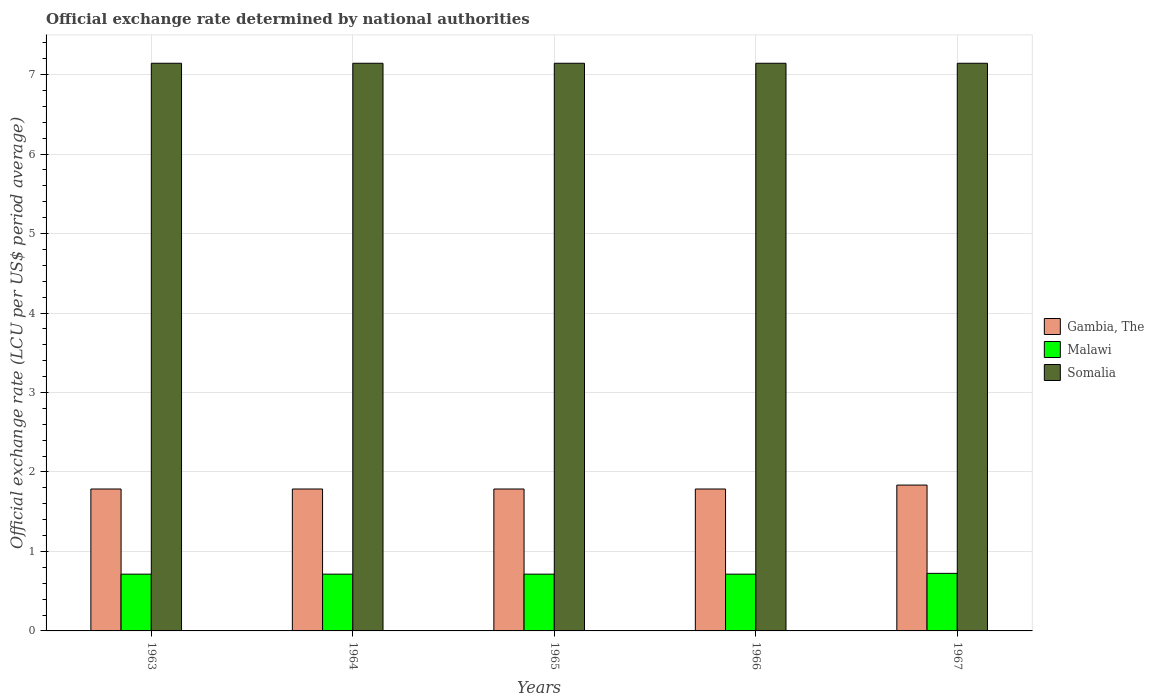How many groups of bars are there?
Your response must be concise. 5. Are the number of bars per tick equal to the number of legend labels?
Provide a succinct answer. Yes. How many bars are there on the 2nd tick from the left?
Offer a very short reply. 3. What is the label of the 5th group of bars from the left?
Ensure brevity in your answer.  1967. In how many cases, is the number of bars for a given year not equal to the number of legend labels?
Your answer should be compact. 0. What is the official exchange rate in Malawi in 1964?
Keep it short and to the point. 0.71. Across all years, what is the maximum official exchange rate in Gambia, The?
Your response must be concise. 1.84. Across all years, what is the minimum official exchange rate in Malawi?
Provide a succinct answer. 0.71. In which year was the official exchange rate in Malawi maximum?
Your answer should be very brief. 1967. What is the total official exchange rate in Gambia, The in the graph?
Provide a short and direct response. 8.98. What is the difference between the official exchange rate in Somalia in 1965 and the official exchange rate in Gambia, The in 1967?
Provide a short and direct response. 5.31. What is the average official exchange rate in Gambia, The per year?
Offer a terse response. 1.8. In the year 1964, what is the difference between the official exchange rate in Somalia and official exchange rate in Gambia, The?
Offer a terse response. 5.36. What is the ratio of the official exchange rate in Malawi in 1963 to that in 1964?
Offer a terse response. 1. Is the official exchange rate in Gambia, The in 1965 less than that in 1966?
Provide a short and direct response. No. What is the difference between the highest and the second highest official exchange rate in Gambia, The?
Offer a very short reply. 0.05. In how many years, is the official exchange rate in Malawi greater than the average official exchange rate in Malawi taken over all years?
Your answer should be very brief. 1. Is the sum of the official exchange rate in Somalia in 1963 and 1964 greater than the maximum official exchange rate in Malawi across all years?
Your answer should be compact. Yes. What does the 3rd bar from the left in 1963 represents?
Your response must be concise. Somalia. What does the 3rd bar from the right in 1967 represents?
Your answer should be very brief. Gambia, The. Does the graph contain grids?
Offer a terse response. Yes. What is the title of the graph?
Provide a succinct answer. Official exchange rate determined by national authorities. Does "Serbia" appear as one of the legend labels in the graph?
Provide a short and direct response. No. What is the label or title of the Y-axis?
Keep it short and to the point. Official exchange rate (LCU per US$ period average). What is the Official exchange rate (LCU per US$ period average) of Gambia, The in 1963?
Your response must be concise. 1.79. What is the Official exchange rate (LCU per US$ period average) of Malawi in 1963?
Offer a very short reply. 0.71. What is the Official exchange rate (LCU per US$ period average) of Somalia in 1963?
Your answer should be very brief. 7.14. What is the Official exchange rate (LCU per US$ period average) of Gambia, The in 1964?
Provide a succinct answer. 1.79. What is the Official exchange rate (LCU per US$ period average) of Malawi in 1964?
Provide a short and direct response. 0.71. What is the Official exchange rate (LCU per US$ period average) of Somalia in 1964?
Your response must be concise. 7.14. What is the Official exchange rate (LCU per US$ period average) of Gambia, The in 1965?
Provide a short and direct response. 1.79. What is the Official exchange rate (LCU per US$ period average) in Malawi in 1965?
Offer a very short reply. 0.71. What is the Official exchange rate (LCU per US$ period average) of Somalia in 1965?
Your response must be concise. 7.14. What is the Official exchange rate (LCU per US$ period average) of Gambia, The in 1966?
Your response must be concise. 1.79. What is the Official exchange rate (LCU per US$ period average) of Malawi in 1966?
Provide a succinct answer. 0.71. What is the Official exchange rate (LCU per US$ period average) of Somalia in 1966?
Provide a short and direct response. 7.14. What is the Official exchange rate (LCU per US$ period average) in Gambia, The in 1967?
Your response must be concise. 1.84. What is the Official exchange rate (LCU per US$ period average) in Malawi in 1967?
Make the answer very short. 0.72. What is the Official exchange rate (LCU per US$ period average) of Somalia in 1967?
Keep it short and to the point. 7.14. Across all years, what is the maximum Official exchange rate (LCU per US$ period average) of Gambia, The?
Your response must be concise. 1.84. Across all years, what is the maximum Official exchange rate (LCU per US$ period average) in Malawi?
Give a very brief answer. 0.72. Across all years, what is the maximum Official exchange rate (LCU per US$ period average) of Somalia?
Keep it short and to the point. 7.14. Across all years, what is the minimum Official exchange rate (LCU per US$ period average) of Gambia, The?
Your answer should be compact. 1.79. Across all years, what is the minimum Official exchange rate (LCU per US$ period average) of Malawi?
Ensure brevity in your answer.  0.71. Across all years, what is the minimum Official exchange rate (LCU per US$ period average) of Somalia?
Keep it short and to the point. 7.14. What is the total Official exchange rate (LCU per US$ period average) of Gambia, The in the graph?
Provide a short and direct response. 8.98. What is the total Official exchange rate (LCU per US$ period average) of Malawi in the graph?
Give a very brief answer. 3.58. What is the total Official exchange rate (LCU per US$ period average) of Somalia in the graph?
Offer a terse response. 35.71. What is the difference between the Official exchange rate (LCU per US$ period average) of Gambia, The in 1963 and that in 1964?
Offer a very short reply. 0. What is the difference between the Official exchange rate (LCU per US$ period average) of Malawi in 1963 and that in 1965?
Make the answer very short. 0. What is the difference between the Official exchange rate (LCU per US$ period average) of Somalia in 1963 and that in 1965?
Make the answer very short. 0. What is the difference between the Official exchange rate (LCU per US$ period average) of Malawi in 1963 and that in 1966?
Your answer should be compact. 0. What is the difference between the Official exchange rate (LCU per US$ period average) in Gambia, The in 1963 and that in 1967?
Your answer should be compact. -0.05. What is the difference between the Official exchange rate (LCU per US$ period average) in Malawi in 1963 and that in 1967?
Give a very brief answer. -0.01. What is the difference between the Official exchange rate (LCU per US$ period average) in Somalia in 1963 and that in 1967?
Your response must be concise. 0. What is the difference between the Official exchange rate (LCU per US$ period average) in Somalia in 1964 and that in 1965?
Provide a short and direct response. 0. What is the difference between the Official exchange rate (LCU per US$ period average) in Gambia, The in 1964 and that in 1966?
Keep it short and to the point. 0. What is the difference between the Official exchange rate (LCU per US$ period average) in Malawi in 1964 and that in 1966?
Ensure brevity in your answer.  0. What is the difference between the Official exchange rate (LCU per US$ period average) of Gambia, The in 1964 and that in 1967?
Provide a succinct answer. -0.05. What is the difference between the Official exchange rate (LCU per US$ period average) in Malawi in 1964 and that in 1967?
Your answer should be compact. -0.01. What is the difference between the Official exchange rate (LCU per US$ period average) of Gambia, The in 1965 and that in 1966?
Your response must be concise. 0. What is the difference between the Official exchange rate (LCU per US$ period average) in Gambia, The in 1965 and that in 1967?
Offer a terse response. -0.05. What is the difference between the Official exchange rate (LCU per US$ period average) in Malawi in 1965 and that in 1967?
Offer a terse response. -0.01. What is the difference between the Official exchange rate (LCU per US$ period average) in Gambia, The in 1966 and that in 1967?
Make the answer very short. -0.05. What is the difference between the Official exchange rate (LCU per US$ period average) in Malawi in 1966 and that in 1967?
Your response must be concise. -0.01. What is the difference between the Official exchange rate (LCU per US$ period average) of Somalia in 1966 and that in 1967?
Ensure brevity in your answer.  0. What is the difference between the Official exchange rate (LCU per US$ period average) of Gambia, The in 1963 and the Official exchange rate (LCU per US$ period average) of Malawi in 1964?
Your answer should be very brief. 1.07. What is the difference between the Official exchange rate (LCU per US$ period average) of Gambia, The in 1963 and the Official exchange rate (LCU per US$ period average) of Somalia in 1964?
Provide a short and direct response. -5.36. What is the difference between the Official exchange rate (LCU per US$ period average) in Malawi in 1963 and the Official exchange rate (LCU per US$ period average) in Somalia in 1964?
Your response must be concise. -6.43. What is the difference between the Official exchange rate (LCU per US$ period average) of Gambia, The in 1963 and the Official exchange rate (LCU per US$ period average) of Malawi in 1965?
Provide a succinct answer. 1.07. What is the difference between the Official exchange rate (LCU per US$ period average) of Gambia, The in 1963 and the Official exchange rate (LCU per US$ period average) of Somalia in 1965?
Your answer should be compact. -5.36. What is the difference between the Official exchange rate (LCU per US$ period average) of Malawi in 1963 and the Official exchange rate (LCU per US$ period average) of Somalia in 1965?
Give a very brief answer. -6.43. What is the difference between the Official exchange rate (LCU per US$ period average) in Gambia, The in 1963 and the Official exchange rate (LCU per US$ period average) in Malawi in 1966?
Keep it short and to the point. 1.07. What is the difference between the Official exchange rate (LCU per US$ period average) in Gambia, The in 1963 and the Official exchange rate (LCU per US$ period average) in Somalia in 1966?
Provide a succinct answer. -5.36. What is the difference between the Official exchange rate (LCU per US$ period average) in Malawi in 1963 and the Official exchange rate (LCU per US$ period average) in Somalia in 1966?
Offer a very short reply. -6.43. What is the difference between the Official exchange rate (LCU per US$ period average) in Gambia, The in 1963 and the Official exchange rate (LCU per US$ period average) in Malawi in 1967?
Make the answer very short. 1.06. What is the difference between the Official exchange rate (LCU per US$ period average) in Gambia, The in 1963 and the Official exchange rate (LCU per US$ period average) in Somalia in 1967?
Give a very brief answer. -5.36. What is the difference between the Official exchange rate (LCU per US$ period average) in Malawi in 1963 and the Official exchange rate (LCU per US$ period average) in Somalia in 1967?
Keep it short and to the point. -6.43. What is the difference between the Official exchange rate (LCU per US$ period average) of Gambia, The in 1964 and the Official exchange rate (LCU per US$ period average) of Malawi in 1965?
Offer a very short reply. 1.07. What is the difference between the Official exchange rate (LCU per US$ period average) in Gambia, The in 1964 and the Official exchange rate (LCU per US$ period average) in Somalia in 1965?
Ensure brevity in your answer.  -5.36. What is the difference between the Official exchange rate (LCU per US$ period average) in Malawi in 1964 and the Official exchange rate (LCU per US$ period average) in Somalia in 1965?
Provide a succinct answer. -6.43. What is the difference between the Official exchange rate (LCU per US$ period average) of Gambia, The in 1964 and the Official exchange rate (LCU per US$ period average) of Malawi in 1966?
Your answer should be very brief. 1.07. What is the difference between the Official exchange rate (LCU per US$ period average) of Gambia, The in 1964 and the Official exchange rate (LCU per US$ period average) of Somalia in 1966?
Your answer should be compact. -5.36. What is the difference between the Official exchange rate (LCU per US$ period average) in Malawi in 1964 and the Official exchange rate (LCU per US$ period average) in Somalia in 1966?
Your answer should be compact. -6.43. What is the difference between the Official exchange rate (LCU per US$ period average) of Gambia, The in 1964 and the Official exchange rate (LCU per US$ period average) of Malawi in 1967?
Give a very brief answer. 1.06. What is the difference between the Official exchange rate (LCU per US$ period average) of Gambia, The in 1964 and the Official exchange rate (LCU per US$ period average) of Somalia in 1967?
Your answer should be compact. -5.36. What is the difference between the Official exchange rate (LCU per US$ period average) of Malawi in 1964 and the Official exchange rate (LCU per US$ period average) of Somalia in 1967?
Offer a terse response. -6.43. What is the difference between the Official exchange rate (LCU per US$ period average) in Gambia, The in 1965 and the Official exchange rate (LCU per US$ period average) in Malawi in 1966?
Give a very brief answer. 1.07. What is the difference between the Official exchange rate (LCU per US$ period average) in Gambia, The in 1965 and the Official exchange rate (LCU per US$ period average) in Somalia in 1966?
Offer a terse response. -5.36. What is the difference between the Official exchange rate (LCU per US$ period average) in Malawi in 1965 and the Official exchange rate (LCU per US$ period average) in Somalia in 1966?
Make the answer very short. -6.43. What is the difference between the Official exchange rate (LCU per US$ period average) in Gambia, The in 1965 and the Official exchange rate (LCU per US$ period average) in Malawi in 1967?
Offer a terse response. 1.06. What is the difference between the Official exchange rate (LCU per US$ period average) of Gambia, The in 1965 and the Official exchange rate (LCU per US$ period average) of Somalia in 1967?
Your answer should be very brief. -5.36. What is the difference between the Official exchange rate (LCU per US$ period average) of Malawi in 1965 and the Official exchange rate (LCU per US$ period average) of Somalia in 1967?
Your response must be concise. -6.43. What is the difference between the Official exchange rate (LCU per US$ period average) in Gambia, The in 1966 and the Official exchange rate (LCU per US$ period average) in Malawi in 1967?
Your response must be concise. 1.06. What is the difference between the Official exchange rate (LCU per US$ period average) in Gambia, The in 1966 and the Official exchange rate (LCU per US$ period average) in Somalia in 1967?
Offer a very short reply. -5.36. What is the difference between the Official exchange rate (LCU per US$ period average) of Malawi in 1966 and the Official exchange rate (LCU per US$ period average) of Somalia in 1967?
Keep it short and to the point. -6.43. What is the average Official exchange rate (LCU per US$ period average) of Gambia, The per year?
Make the answer very short. 1.8. What is the average Official exchange rate (LCU per US$ period average) in Malawi per year?
Ensure brevity in your answer.  0.72. What is the average Official exchange rate (LCU per US$ period average) in Somalia per year?
Offer a terse response. 7.14. In the year 1963, what is the difference between the Official exchange rate (LCU per US$ period average) in Gambia, The and Official exchange rate (LCU per US$ period average) in Malawi?
Keep it short and to the point. 1.07. In the year 1963, what is the difference between the Official exchange rate (LCU per US$ period average) in Gambia, The and Official exchange rate (LCU per US$ period average) in Somalia?
Give a very brief answer. -5.36. In the year 1963, what is the difference between the Official exchange rate (LCU per US$ period average) of Malawi and Official exchange rate (LCU per US$ period average) of Somalia?
Offer a very short reply. -6.43. In the year 1964, what is the difference between the Official exchange rate (LCU per US$ period average) in Gambia, The and Official exchange rate (LCU per US$ period average) in Malawi?
Your response must be concise. 1.07. In the year 1964, what is the difference between the Official exchange rate (LCU per US$ period average) of Gambia, The and Official exchange rate (LCU per US$ period average) of Somalia?
Provide a short and direct response. -5.36. In the year 1964, what is the difference between the Official exchange rate (LCU per US$ period average) in Malawi and Official exchange rate (LCU per US$ period average) in Somalia?
Your answer should be very brief. -6.43. In the year 1965, what is the difference between the Official exchange rate (LCU per US$ period average) of Gambia, The and Official exchange rate (LCU per US$ period average) of Malawi?
Provide a succinct answer. 1.07. In the year 1965, what is the difference between the Official exchange rate (LCU per US$ period average) in Gambia, The and Official exchange rate (LCU per US$ period average) in Somalia?
Keep it short and to the point. -5.36. In the year 1965, what is the difference between the Official exchange rate (LCU per US$ period average) of Malawi and Official exchange rate (LCU per US$ period average) of Somalia?
Make the answer very short. -6.43. In the year 1966, what is the difference between the Official exchange rate (LCU per US$ period average) of Gambia, The and Official exchange rate (LCU per US$ period average) of Malawi?
Your answer should be very brief. 1.07. In the year 1966, what is the difference between the Official exchange rate (LCU per US$ period average) of Gambia, The and Official exchange rate (LCU per US$ period average) of Somalia?
Offer a terse response. -5.36. In the year 1966, what is the difference between the Official exchange rate (LCU per US$ period average) of Malawi and Official exchange rate (LCU per US$ period average) of Somalia?
Your response must be concise. -6.43. In the year 1967, what is the difference between the Official exchange rate (LCU per US$ period average) of Gambia, The and Official exchange rate (LCU per US$ period average) of Malawi?
Offer a very short reply. 1.11. In the year 1967, what is the difference between the Official exchange rate (LCU per US$ period average) in Gambia, The and Official exchange rate (LCU per US$ period average) in Somalia?
Offer a terse response. -5.31. In the year 1967, what is the difference between the Official exchange rate (LCU per US$ period average) in Malawi and Official exchange rate (LCU per US$ period average) in Somalia?
Ensure brevity in your answer.  -6.42. What is the ratio of the Official exchange rate (LCU per US$ period average) of Malawi in 1963 to that in 1964?
Make the answer very short. 1. What is the ratio of the Official exchange rate (LCU per US$ period average) in Somalia in 1963 to that in 1964?
Ensure brevity in your answer.  1. What is the ratio of the Official exchange rate (LCU per US$ period average) of Gambia, The in 1963 to that in 1965?
Give a very brief answer. 1. What is the ratio of the Official exchange rate (LCU per US$ period average) of Somalia in 1963 to that in 1965?
Your answer should be compact. 1. What is the ratio of the Official exchange rate (LCU per US$ period average) of Gambia, The in 1963 to that in 1966?
Provide a short and direct response. 1. What is the ratio of the Official exchange rate (LCU per US$ period average) in Malawi in 1963 to that in 1966?
Provide a short and direct response. 1. What is the ratio of the Official exchange rate (LCU per US$ period average) in Somalia in 1963 to that in 1966?
Offer a very short reply. 1. What is the ratio of the Official exchange rate (LCU per US$ period average) of Malawi in 1963 to that in 1967?
Keep it short and to the point. 0.99. What is the ratio of the Official exchange rate (LCU per US$ period average) in Somalia in 1963 to that in 1967?
Your response must be concise. 1. What is the ratio of the Official exchange rate (LCU per US$ period average) in Gambia, The in 1964 to that in 1965?
Provide a succinct answer. 1. What is the ratio of the Official exchange rate (LCU per US$ period average) of Malawi in 1964 to that in 1965?
Your answer should be compact. 1. What is the ratio of the Official exchange rate (LCU per US$ period average) of Gambia, The in 1964 to that in 1966?
Your answer should be very brief. 1. What is the ratio of the Official exchange rate (LCU per US$ period average) of Gambia, The in 1964 to that in 1967?
Keep it short and to the point. 0.97. What is the ratio of the Official exchange rate (LCU per US$ period average) in Malawi in 1964 to that in 1967?
Your response must be concise. 0.99. What is the ratio of the Official exchange rate (LCU per US$ period average) in Malawi in 1965 to that in 1966?
Your answer should be compact. 1. What is the ratio of the Official exchange rate (LCU per US$ period average) in Somalia in 1965 to that in 1966?
Your response must be concise. 1. What is the ratio of the Official exchange rate (LCU per US$ period average) of Malawi in 1965 to that in 1967?
Your answer should be compact. 0.99. What is the ratio of the Official exchange rate (LCU per US$ period average) of Somalia in 1965 to that in 1967?
Offer a terse response. 1. What is the ratio of the Official exchange rate (LCU per US$ period average) in Gambia, The in 1966 to that in 1967?
Keep it short and to the point. 0.97. What is the ratio of the Official exchange rate (LCU per US$ period average) in Malawi in 1966 to that in 1967?
Offer a terse response. 0.99. What is the ratio of the Official exchange rate (LCU per US$ period average) in Somalia in 1966 to that in 1967?
Your response must be concise. 1. What is the difference between the highest and the second highest Official exchange rate (LCU per US$ period average) of Gambia, The?
Keep it short and to the point. 0.05. What is the difference between the highest and the second highest Official exchange rate (LCU per US$ period average) in Malawi?
Keep it short and to the point. 0.01. What is the difference between the highest and the second highest Official exchange rate (LCU per US$ period average) in Somalia?
Ensure brevity in your answer.  0. What is the difference between the highest and the lowest Official exchange rate (LCU per US$ period average) of Gambia, The?
Offer a very short reply. 0.05. What is the difference between the highest and the lowest Official exchange rate (LCU per US$ period average) in Malawi?
Make the answer very short. 0.01. 